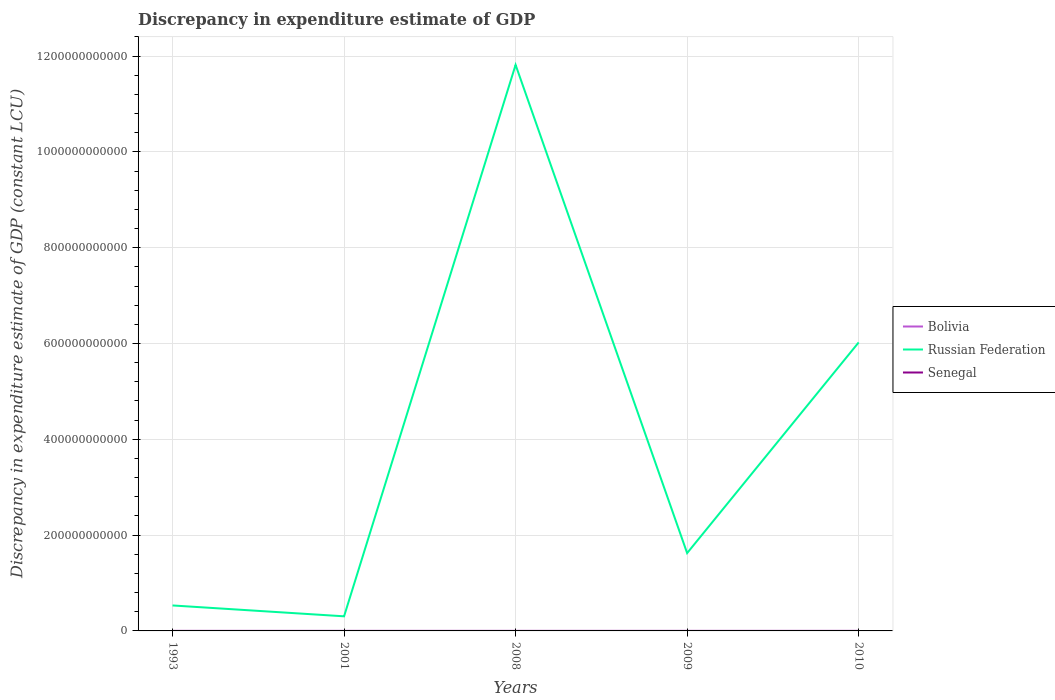Is the number of lines equal to the number of legend labels?
Offer a terse response. No. What is the total discrepancy in expenditure estimate of GDP in Senegal in the graph?
Offer a terse response. 0. How many years are there in the graph?
Make the answer very short. 5. What is the difference between two consecutive major ticks on the Y-axis?
Your response must be concise. 2.00e+11. Are the values on the major ticks of Y-axis written in scientific E-notation?
Ensure brevity in your answer.  No. Does the graph contain any zero values?
Make the answer very short. Yes. Does the graph contain grids?
Provide a succinct answer. Yes. Where does the legend appear in the graph?
Offer a very short reply. Center right. How are the legend labels stacked?
Provide a succinct answer. Vertical. What is the title of the graph?
Provide a succinct answer. Discrepancy in expenditure estimate of GDP. Does "East Asia (all income levels)" appear as one of the legend labels in the graph?
Offer a very short reply. No. What is the label or title of the X-axis?
Your answer should be very brief. Years. What is the label or title of the Y-axis?
Your response must be concise. Discrepancy in expenditure estimate of GDP (constant LCU). What is the Discrepancy in expenditure estimate of GDP (constant LCU) in Russian Federation in 1993?
Your answer should be compact. 5.32e+1. What is the Discrepancy in expenditure estimate of GDP (constant LCU) in Senegal in 1993?
Provide a short and direct response. 100. What is the Discrepancy in expenditure estimate of GDP (constant LCU) in Russian Federation in 2001?
Give a very brief answer. 3.05e+1. What is the Discrepancy in expenditure estimate of GDP (constant LCU) of Bolivia in 2008?
Provide a short and direct response. 1100. What is the Discrepancy in expenditure estimate of GDP (constant LCU) of Russian Federation in 2008?
Your response must be concise. 1.18e+12. What is the Discrepancy in expenditure estimate of GDP (constant LCU) in Bolivia in 2009?
Your answer should be compact. 1100. What is the Discrepancy in expenditure estimate of GDP (constant LCU) in Russian Federation in 2009?
Your answer should be compact. 1.62e+11. What is the Discrepancy in expenditure estimate of GDP (constant LCU) in Bolivia in 2010?
Provide a succinct answer. 1100. What is the Discrepancy in expenditure estimate of GDP (constant LCU) in Russian Federation in 2010?
Offer a terse response. 6.02e+11. Across all years, what is the maximum Discrepancy in expenditure estimate of GDP (constant LCU) of Bolivia?
Give a very brief answer. 1100. Across all years, what is the maximum Discrepancy in expenditure estimate of GDP (constant LCU) of Russian Federation?
Your answer should be compact. 1.18e+12. Across all years, what is the maximum Discrepancy in expenditure estimate of GDP (constant LCU) of Senegal?
Offer a terse response. 100. Across all years, what is the minimum Discrepancy in expenditure estimate of GDP (constant LCU) in Bolivia?
Keep it short and to the point. 0. Across all years, what is the minimum Discrepancy in expenditure estimate of GDP (constant LCU) of Russian Federation?
Provide a succinct answer. 3.05e+1. What is the total Discrepancy in expenditure estimate of GDP (constant LCU) of Bolivia in the graph?
Offer a terse response. 3700. What is the total Discrepancy in expenditure estimate of GDP (constant LCU) in Russian Federation in the graph?
Your answer should be compact. 2.03e+12. What is the total Discrepancy in expenditure estimate of GDP (constant LCU) of Senegal in the graph?
Your answer should be very brief. 500. What is the difference between the Discrepancy in expenditure estimate of GDP (constant LCU) of Russian Federation in 1993 and that in 2001?
Make the answer very short. 2.27e+1. What is the difference between the Discrepancy in expenditure estimate of GDP (constant LCU) of Senegal in 1993 and that in 2001?
Make the answer very short. 0. What is the difference between the Discrepancy in expenditure estimate of GDP (constant LCU) of Bolivia in 1993 and that in 2008?
Offer a very short reply. -700. What is the difference between the Discrepancy in expenditure estimate of GDP (constant LCU) of Russian Federation in 1993 and that in 2008?
Offer a very short reply. -1.13e+12. What is the difference between the Discrepancy in expenditure estimate of GDP (constant LCU) in Bolivia in 1993 and that in 2009?
Offer a terse response. -700. What is the difference between the Discrepancy in expenditure estimate of GDP (constant LCU) in Russian Federation in 1993 and that in 2009?
Ensure brevity in your answer.  -1.09e+11. What is the difference between the Discrepancy in expenditure estimate of GDP (constant LCU) of Senegal in 1993 and that in 2009?
Your response must be concise. 0. What is the difference between the Discrepancy in expenditure estimate of GDP (constant LCU) in Bolivia in 1993 and that in 2010?
Your response must be concise. -700. What is the difference between the Discrepancy in expenditure estimate of GDP (constant LCU) of Russian Federation in 1993 and that in 2010?
Provide a succinct answer. -5.49e+11. What is the difference between the Discrepancy in expenditure estimate of GDP (constant LCU) in Russian Federation in 2001 and that in 2008?
Your answer should be very brief. -1.15e+12. What is the difference between the Discrepancy in expenditure estimate of GDP (constant LCU) in Senegal in 2001 and that in 2008?
Provide a succinct answer. 0. What is the difference between the Discrepancy in expenditure estimate of GDP (constant LCU) of Russian Federation in 2001 and that in 2009?
Your answer should be very brief. -1.32e+11. What is the difference between the Discrepancy in expenditure estimate of GDP (constant LCU) in Russian Federation in 2001 and that in 2010?
Provide a short and direct response. -5.72e+11. What is the difference between the Discrepancy in expenditure estimate of GDP (constant LCU) in Senegal in 2001 and that in 2010?
Make the answer very short. 0. What is the difference between the Discrepancy in expenditure estimate of GDP (constant LCU) of Russian Federation in 2008 and that in 2009?
Make the answer very short. 1.02e+12. What is the difference between the Discrepancy in expenditure estimate of GDP (constant LCU) in Senegal in 2008 and that in 2009?
Make the answer very short. 0. What is the difference between the Discrepancy in expenditure estimate of GDP (constant LCU) of Bolivia in 2008 and that in 2010?
Keep it short and to the point. 0. What is the difference between the Discrepancy in expenditure estimate of GDP (constant LCU) of Russian Federation in 2008 and that in 2010?
Your response must be concise. 5.79e+11. What is the difference between the Discrepancy in expenditure estimate of GDP (constant LCU) in Bolivia in 2009 and that in 2010?
Offer a very short reply. 0. What is the difference between the Discrepancy in expenditure estimate of GDP (constant LCU) in Russian Federation in 2009 and that in 2010?
Your response must be concise. -4.40e+11. What is the difference between the Discrepancy in expenditure estimate of GDP (constant LCU) of Senegal in 2009 and that in 2010?
Provide a succinct answer. 0. What is the difference between the Discrepancy in expenditure estimate of GDP (constant LCU) in Bolivia in 1993 and the Discrepancy in expenditure estimate of GDP (constant LCU) in Russian Federation in 2001?
Ensure brevity in your answer.  -3.05e+1. What is the difference between the Discrepancy in expenditure estimate of GDP (constant LCU) in Bolivia in 1993 and the Discrepancy in expenditure estimate of GDP (constant LCU) in Senegal in 2001?
Keep it short and to the point. 300. What is the difference between the Discrepancy in expenditure estimate of GDP (constant LCU) of Russian Federation in 1993 and the Discrepancy in expenditure estimate of GDP (constant LCU) of Senegal in 2001?
Give a very brief answer. 5.32e+1. What is the difference between the Discrepancy in expenditure estimate of GDP (constant LCU) of Bolivia in 1993 and the Discrepancy in expenditure estimate of GDP (constant LCU) of Russian Federation in 2008?
Keep it short and to the point. -1.18e+12. What is the difference between the Discrepancy in expenditure estimate of GDP (constant LCU) of Bolivia in 1993 and the Discrepancy in expenditure estimate of GDP (constant LCU) of Senegal in 2008?
Make the answer very short. 300. What is the difference between the Discrepancy in expenditure estimate of GDP (constant LCU) in Russian Federation in 1993 and the Discrepancy in expenditure estimate of GDP (constant LCU) in Senegal in 2008?
Provide a succinct answer. 5.32e+1. What is the difference between the Discrepancy in expenditure estimate of GDP (constant LCU) of Bolivia in 1993 and the Discrepancy in expenditure estimate of GDP (constant LCU) of Russian Federation in 2009?
Give a very brief answer. -1.62e+11. What is the difference between the Discrepancy in expenditure estimate of GDP (constant LCU) of Bolivia in 1993 and the Discrepancy in expenditure estimate of GDP (constant LCU) of Senegal in 2009?
Your answer should be compact. 300. What is the difference between the Discrepancy in expenditure estimate of GDP (constant LCU) of Russian Federation in 1993 and the Discrepancy in expenditure estimate of GDP (constant LCU) of Senegal in 2009?
Your response must be concise. 5.32e+1. What is the difference between the Discrepancy in expenditure estimate of GDP (constant LCU) of Bolivia in 1993 and the Discrepancy in expenditure estimate of GDP (constant LCU) of Russian Federation in 2010?
Your answer should be very brief. -6.02e+11. What is the difference between the Discrepancy in expenditure estimate of GDP (constant LCU) in Bolivia in 1993 and the Discrepancy in expenditure estimate of GDP (constant LCU) in Senegal in 2010?
Give a very brief answer. 300. What is the difference between the Discrepancy in expenditure estimate of GDP (constant LCU) of Russian Federation in 1993 and the Discrepancy in expenditure estimate of GDP (constant LCU) of Senegal in 2010?
Make the answer very short. 5.32e+1. What is the difference between the Discrepancy in expenditure estimate of GDP (constant LCU) in Russian Federation in 2001 and the Discrepancy in expenditure estimate of GDP (constant LCU) in Senegal in 2008?
Offer a terse response. 3.05e+1. What is the difference between the Discrepancy in expenditure estimate of GDP (constant LCU) in Russian Federation in 2001 and the Discrepancy in expenditure estimate of GDP (constant LCU) in Senegal in 2009?
Provide a short and direct response. 3.05e+1. What is the difference between the Discrepancy in expenditure estimate of GDP (constant LCU) of Russian Federation in 2001 and the Discrepancy in expenditure estimate of GDP (constant LCU) of Senegal in 2010?
Ensure brevity in your answer.  3.05e+1. What is the difference between the Discrepancy in expenditure estimate of GDP (constant LCU) of Bolivia in 2008 and the Discrepancy in expenditure estimate of GDP (constant LCU) of Russian Federation in 2009?
Keep it short and to the point. -1.62e+11. What is the difference between the Discrepancy in expenditure estimate of GDP (constant LCU) of Russian Federation in 2008 and the Discrepancy in expenditure estimate of GDP (constant LCU) of Senegal in 2009?
Your response must be concise. 1.18e+12. What is the difference between the Discrepancy in expenditure estimate of GDP (constant LCU) of Bolivia in 2008 and the Discrepancy in expenditure estimate of GDP (constant LCU) of Russian Federation in 2010?
Offer a very short reply. -6.02e+11. What is the difference between the Discrepancy in expenditure estimate of GDP (constant LCU) of Russian Federation in 2008 and the Discrepancy in expenditure estimate of GDP (constant LCU) of Senegal in 2010?
Your answer should be very brief. 1.18e+12. What is the difference between the Discrepancy in expenditure estimate of GDP (constant LCU) of Bolivia in 2009 and the Discrepancy in expenditure estimate of GDP (constant LCU) of Russian Federation in 2010?
Give a very brief answer. -6.02e+11. What is the difference between the Discrepancy in expenditure estimate of GDP (constant LCU) in Bolivia in 2009 and the Discrepancy in expenditure estimate of GDP (constant LCU) in Senegal in 2010?
Keep it short and to the point. 1000. What is the difference between the Discrepancy in expenditure estimate of GDP (constant LCU) in Russian Federation in 2009 and the Discrepancy in expenditure estimate of GDP (constant LCU) in Senegal in 2010?
Your response must be concise. 1.62e+11. What is the average Discrepancy in expenditure estimate of GDP (constant LCU) in Bolivia per year?
Provide a succinct answer. 740. What is the average Discrepancy in expenditure estimate of GDP (constant LCU) of Russian Federation per year?
Your response must be concise. 4.06e+11. What is the average Discrepancy in expenditure estimate of GDP (constant LCU) in Senegal per year?
Give a very brief answer. 100. In the year 1993, what is the difference between the Discrepancy in expenditure estimate of GDP (constant LCU) in Bolivia and Discrepancy in expenditure estimate of GDP (constant LCU) in Russian Federation?
Offer a very short reply. -5.32e+1. In the year 1993, what is the difference between the Discrepancy in expenditure estimate of GDP (constant LCU) of Bolivia and Discrepancy in expenditure estimate of GDP (constant LCU) of Senegal?
Keep it short and to the point. 300. In the year 1993, what is the difference between the Discrepancy in expenditure estimate of GDP (constant LCU) in Russian Federation and Discrepancy in expenditure estimate of GDP (constant LCU) in Senegal?
Your response must be concise. 5.32e+1. In the year 2001, what is the difference between the Discrepancy in expenditure estimate of GDP (constant LCU) in Russian Federation and Discrepancy in expenditure estimate of GDP (constant LCU) in Senegal?
Your response must be concise. 3.05e+1. In the year 2008, what is the difference between the Discrepancy in expenditure estimate of GDP (constant LCU) of Bolivia and Discrepancy in expenditure estimate of GDP (constant LCU) of Russian Federation?
Your answer should be very brief. -1.18e+12. In the year 2008, what is the difference between the Discrepancy in expenditure estimate of GDP (constant LCU) in Bolivia and Discrepancy in expenditure estimate of GDP (constant LCU) in Senegal?
Your answer should be very brief. 1000. In the year 2008, what is the difference between the Discrepancy in expenditure estimate of GDP (constant LCU) in Russian Federation and Discrepancy in expenditure estimate of GDP (constant LCU) in Senegal?
Ensure brevity in your answer.  1.18e+12. In the year 2009, what is the difference between the Discrepancy in expenditure estimate of GDP (constant LCU) of Bolivia and Discrepancy in expenditure estimate of GDP (constant LCU) of Russian Federation?
Your response must be concise. -1.62e+11. In the year 2009, what is the difference between the Discrepancy in expenditure estimate of GDP (constant LCU) of Bolivia and Discrepancy in expenditure estimate of GDP (constant LCU) of Senegal?
Your response must be concise. 1000. In the year 2009, what is the difference between the Discrepancy in expenditure estimate of GDP (constant LCU) of Russian Federation and Discrepancy in expenditure estimate of GDP (constant LCU) of Senegal?
Make the answer very short. 1.62e+11. In the year 2010, what is the difference between the Discrepancy in expenditure estimate of GDP (constant LCU) of Bolivia and Discrepancy in expenditure estimate of GDP (constant LCU) of Russian Federation?
Offer a very short reply. -6.02e+11. In the year 2010, what is the difference between the Discrepancy in expenditure estimate of GDP (constant LCU) in Bolivia and Discrepancy in expenditure estimate of GDP (constant LCU) in Senegal?
Make the answer very short. 1000. In the year 2010, what is the difference between the Discrepancy in expenditure estimate of GDP (constant LCU) of Russian Federation and Discrepancy in expenditure estimate of GDP (constant LCU) of Senegal?
Offer a terse response. 6.02e+11. What is the ratio of the Discrepancy in expenditure estimate of GDP (constant LCU) in Russian Federation in 1993 to that in 2001?
Provide a short and direct response. 1.74. What is the ratio of the Discrepancy in expenditure estimate of GDP (constant LCU) in Bolivia in 1993 to that in 2008?
Provide a succinct answer. 0.36. What is the ratio of the Discrepancy in expenditure estimate of GDP (constant LCU) of Russian Federation in 1993 to that in 2008?
Make the answer very short. 0.04. What is the ratio of the Discrepancy in expenditure estimate of GDP (constant LCU) of Senegal in 1993 to that in 2008?
Provide a succinct answer. 1. What is the ratio of the Discrepancy in expenditure estimate of GDP (constant LCU) of Bolivia in 1993 to that in 2009?
Your answer should be compact. 0.36. What is the ratio of the Discrepancy in expenditure estimate of GDP (constant LCU) of Russian Federation in 1993 to that in 2009?
Offer a terse response. 0.33. What is the ratio of the Discrepancy in expenditure estimate of GDP (constant LCU) of Senegal in 1993 to that in 2009?
Make the answer very short. 1. What is the ratio of the Discrepancy in expenditure estimate of GDP (constant LCU) in Bolivia in 1993 to that in 2010?
Give a very brief answer. 0.36. What is the ratio of the Discrepancy in expenditure estimate of GDP (constant LCU) in Russian Federation in 1993 to that in 2010?
Ensure brevity in your answer.  0.09. What is the ratio of the Discrepancy in expenditure estimate of GDP (constant LCU) in Russian Federation in 2001 to that in 2008?
Offer a very short reply. 0.03. What is the ratio of the Discrepancy in expenditure estimate of GDP (constant LCU) of Russian Federation in 2001 to that in 2009?
Offer a terse response. 0.19. What is the ratio of the Discrepancy in expenditure estimate of GDP (constant LCU) of Senegal in 2001 to that in 2009?
Give a very brief answer. 1. What is the ratio of the Discrepancy in expenditure estimate of GDP (constant LCU) in Russian Federation in 2001 to that in 2010?
Provide a short and direct response. 0.05. What is the ratio of the Discrepancy in expenditure estimate of GDP (constant LCU) in Senegal in 2001 to that in 2010?
Give a very brief answer. 1. What is the ratio of the Discrepancy in expenditure estimate of GDP (constant LCU) in Russian Federation in 2008 to that in 2009?
Ensure brevity in your answer.  7.27. What is the ratio of the Discrepancy in expenditure estimate of GDP (constant LCU) of Senegal in 2008 to that in 2009?
Offer a terse response. 1. What is the ratio of the Discrepancy in expenditure estimate of GDP (constant LCU) of Bolivia in 2008 to that in 2010?
Keep it short and to the point. 1. What is the ratio of the Discrepancy in expenditure estimate of GDP (constant LCU) in Russian Federation in 2008 to that in 2010?
Your answer should be very brief. 1.96. What is the ratio of the Discrepancy in expenditure estimate of GDP (constant LCU) in Senegal in 2008 to that in 2010?
Provide a succinct answer. 1. What is the ratio of the Discrepancy in expenditure estimate of GDP (constant LCU) in Russian Federation in 2009 to that in 2010?
Keep it short and to the point. 0.27. What is the difference between the highest and the second highest Discrepancy in expenditure estimate of GDP (constant LCU) of Russian Federation?
Provide a succinct answer. 5.79e+11. What is the difference between the highest and the lowest Discrepancy in expenditure estimate of GDP (constant LCU) in Bolivia?
Your answer should be very brief. 1100. What is the difference between the highest and the lowest Discrepancy in expenditure estimate of GDP (constant LCU) of Russian Federation?
Make the answer very short. 1.15e+12. What is the difference between the highest and the lowest Discrepancy in expenditure estimate of GDP (constant LCU) of Senegal?
Your answer should be very brief. 0. 